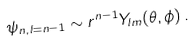<formula> <loc_0><loc_0><loc_500><loc_500>\psi _ { n , l = n - 1 } \sim r ^ { n - 1 } Y _ { l m } ( \theta , \phi ) \, .</formula> 